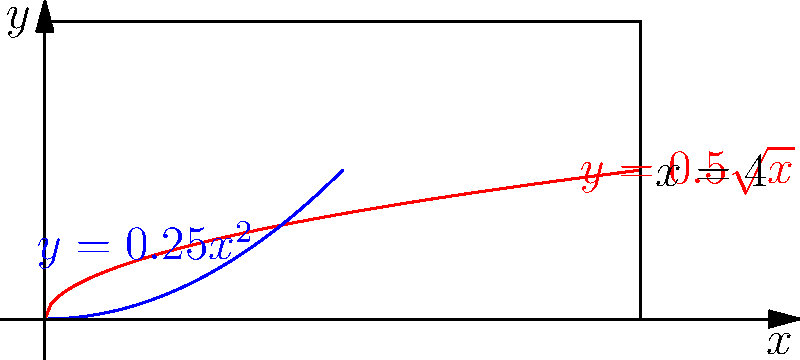As a radio station director, you're designing a uniquely shaped speaker for your studio. The speaker's cross-section is formed by rotating the region bounded by $y=0.5\sqrt{x}$, $y=0.25x^2$, and $x=4$ around the y-axis. Calculate the volume of this speaker using the method of rotational solids. To find the volume of the speaker, we'll use the washer method for rotational solids:

1) First, we need to find the intersection point of the two curves:
   $0.5\sqrt{x} = 0.25x^2$
   $2\sqrt{x} = x^2$
   $4x = x^4$
   $x(4-x^3) = 0$
   $x = 0$ or $x = \sqrt[3]{4} = 1.5874$

2) The volume formula using the washer method is:
   $V = \pi \int_a^b [(R(x))^2 - (r(x))^2] dx$
   where $R(x) = 0.5\sqrt{x}$ and $r(x) = 0.25x^2$

3) Set up the integral:
   $V = \pi \int_{1.5874}^4 [(0.5\sqrt{x})^2 - (0.25x^2)^2] dx$

4) Simplify:
   $V = \pi \int_{1.5874}^4 [0.25x - 0.0625x^4] dx$

5) Integrate:
   $V = \pi [\frac{1}{8}x^2 - \frac{1}{80}x^5]_{1.5874}^4$

6) Evaluate the definite integral:
   $V = \pi [(\frac{1}{8}(4)^2 - \frac{1}{80}(4)^5) - (\frac{1}{8}(1.5874)^2 - \frac{1}{80}(1.5874)^5)]$

7) Calculate the final result:
   $V \approx 3.6416\pi$ cubic units
Answer: $3.6416\pi$ cubic units 